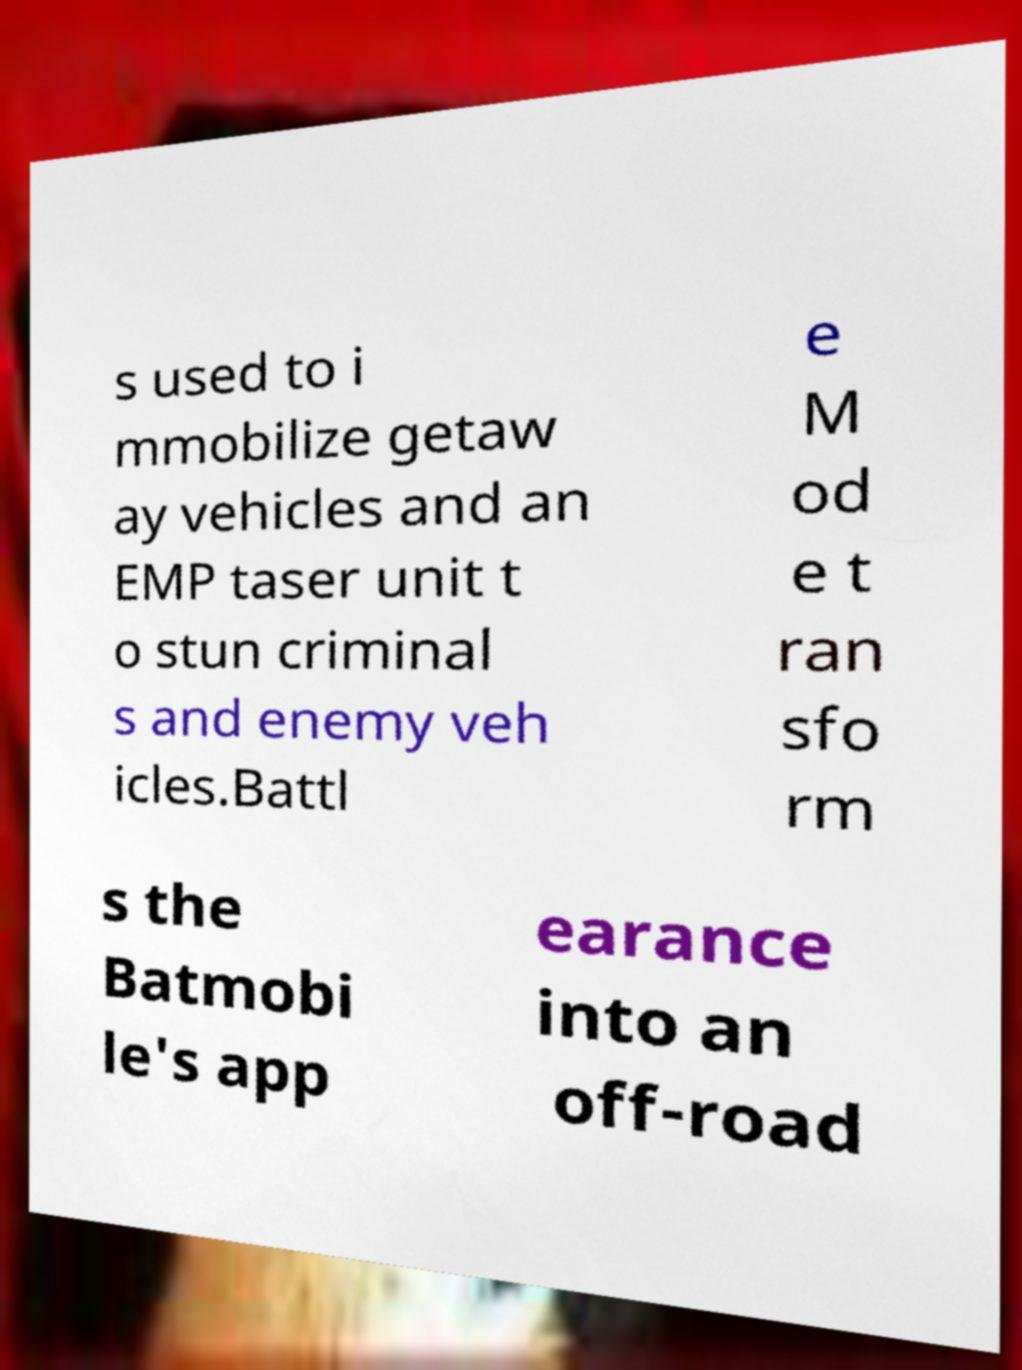Can you read and provide the text displayed in the image?This photo seems to have some interesting text. Can you extract and type it out for me? s used to i mmobilize getaw ay vehicles and an EMP taser unit t o stun criminal s and enemy veh icles.Battl e M od e t ran sfo rm s the Batmobi le's app earance into an off-road 